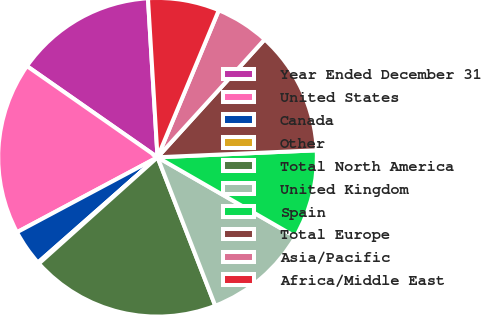Convert chart to OTSL. <chart><loc_0><loc_0><loc_500><loc_500><pie_chart><fcel>Year Ended December 31<fcel>United States<fcel>Canada<fcel>Other<fcel>Total North America<fcel>United Kingdom<fcel>Spain<fcel>Total Europe<fcel>Asia/Pacific<fcel>Africa/Middle East<nl><fcel>14.34%<fcel>17.5%<fcel>3.69%<fcel>0.14%<fcel>19.27%<fcel>10.79%<fcel>9.01%<fcel>12.56%<fcel>5.46%<fcel>7.24%<nl></chart> 